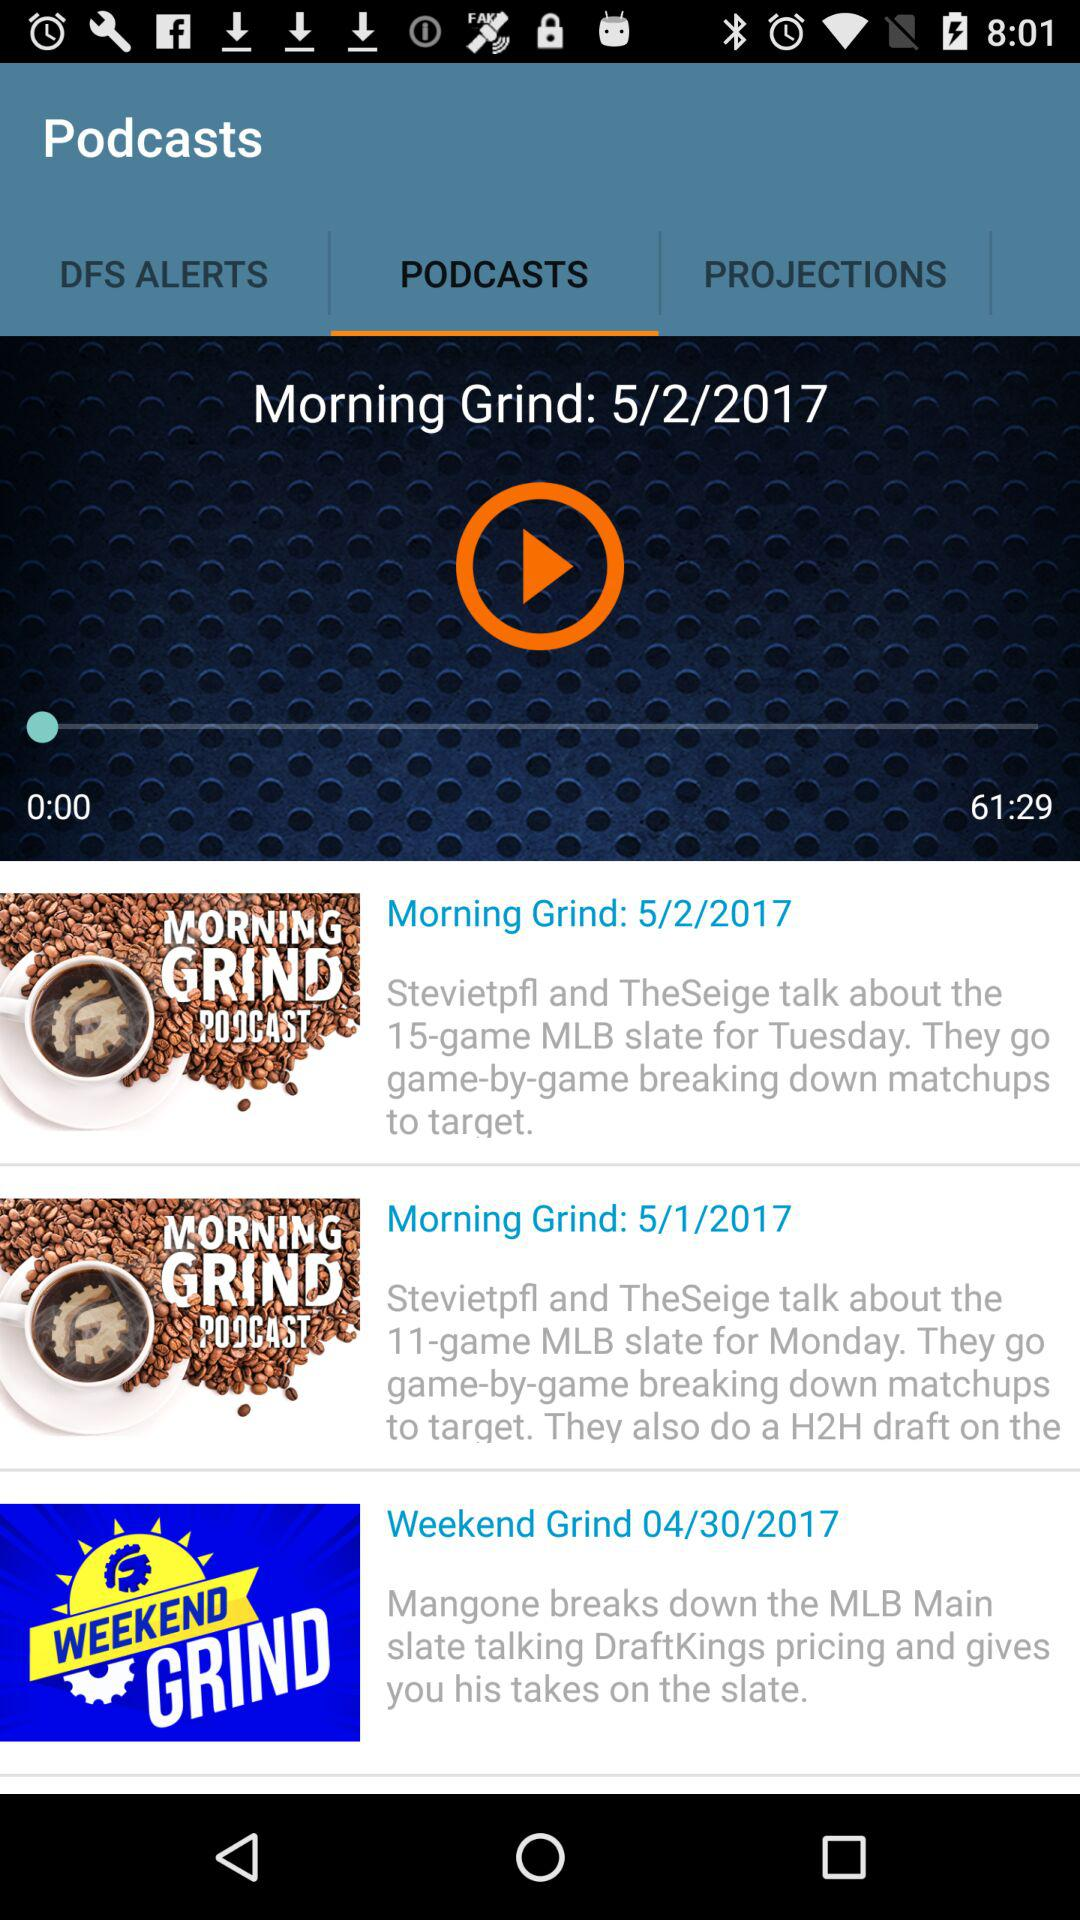What is the app name? The app name is "Podcasts". 